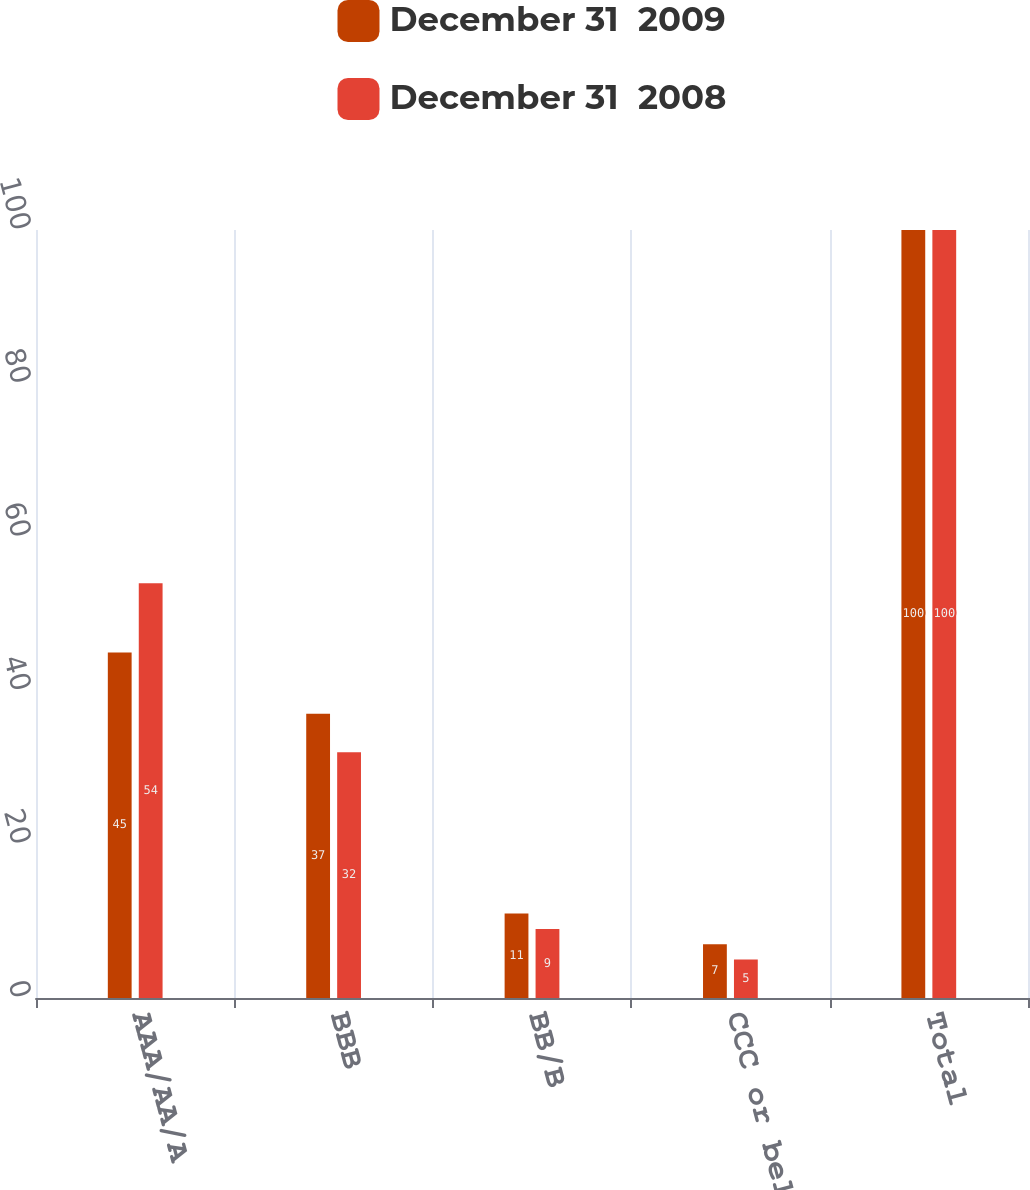Convert chart to OTSL. <chart><loc_0><loc_0><loc_500><loc_500><stacked_bar_chart><ecel><fcel>AAA/AA/A<fcel>BBB<fcel>BB/B<fcel>CCC or below<fcel>Total<nl><fcel>December 31  2009<fcel>45<fcel>37<fcel>11<fcel>7<fcel>100<nl><fcel>December 31  2008<fcel>54<fcel>32<fcel>9<fcel>5<fcel>100<nl></chart> 